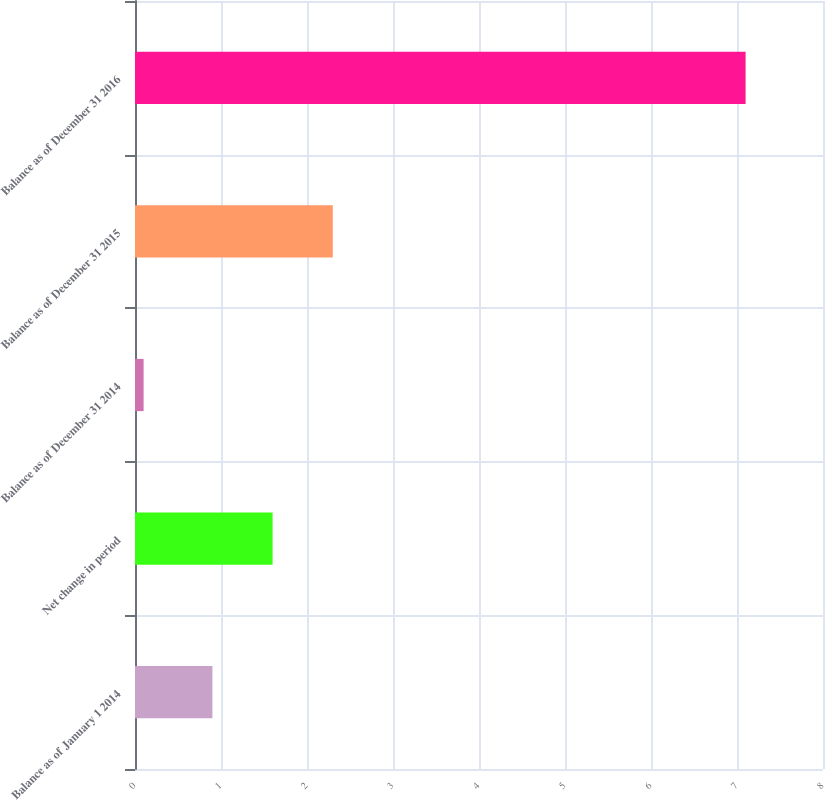Convert chart. <chart><loc_0><loc_0><loc_500><loc_500><bar_chart><fcel>Balance as of January 1 2014<fcel>Net change in period<fcel>Balance as of December 31 2014<fcel>Balance as of December 31 2015<fcel>Balance as of December 31 2016<nl><fcel>0.9<fcel>1.6<fcel>0.1<fcel>2.3<fcel>7.1<nl></chart> 